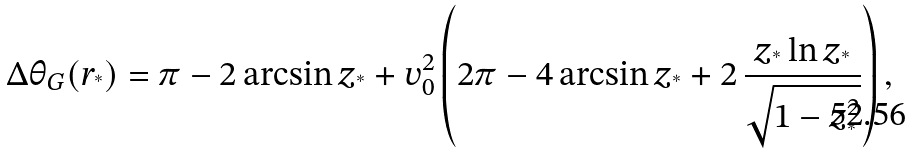Convert formula to latex. <formula><loc_0><loc_0><loc_500><loc_500>\Delta \theta _ { G } ( r _ { ^ { * } } ) = \pi - 2 \arcsin z _ { ^ { * } } + v _ { 0 } ^ { 2 } \left ( 2 \pi - 4 \arcsin z _ { ^ { * } } + 2 \, \frac { z _ { ^ { * } } \ln z _ { ^ { * } } } { \sqrt { 1 - z _ { ^ { * } } ^ { 2 } } } \right ) ,</formula> 